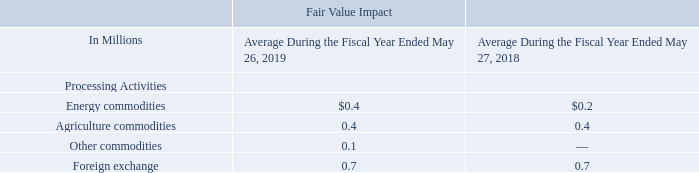Value-at-Risk (VaR)
We employ various tools to monitor our derivative risk, including value-at-risk ("VaR") models. We perform simulations using historical data to estimate potential losses in the fair value of current derivative positions. We use price and volatility information for the prior 90 days in the calculation of VaR that is used to monitor our daily risk. The purpose of this measurement 45 is to provide a single view of the potential risk of loss associated with derivative positions at a given point in time based on recent changes in market prices. Our model uses a 95% confidence level. Accordingly, in any given one-day time period, losses greater than the amounts included in the table below are expected to occur only 5% of the time. We include commodity swaps, futures, and options and foreign exchange forwards, swaps, and options in this calculation. The following table provides an overview of our average daily VaR for our energy, agriculture, and foreign exchange positions for fiscal 2019 and 2018.
How does the company estimate potential losses in the fair value of current derivative positions? Perform simulations using historical data. What does the company use in the calculation of VaR? Price and volatility information for the prior 90 days. What does the table provide for us? An overview of our average daily var for our energy, agriculture, and foreign exchange positions for fiscal 2019 and 2018. Which processing activity has the highest fair value impact during the fiscal year 2019? 0.7>0.4>0.4>0.1
Answer: foreign exchange. What is the percentage change in the average fair value impact of energy commodities from 2018 to 2019?
Answer scale should be: percent. (0.4-0.2)/0.2 
Answer: 100. What is the average fair value impact of all processing activities in the fiscal year 2018?
Answer scale should be: million. (0.2+0.4+0.7)/4 
Answer: 0.33. 